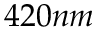Convert formula to latex. <formula><loc_0><loc_0><loc_500><loc_500>4 2 0 n m</formula> 